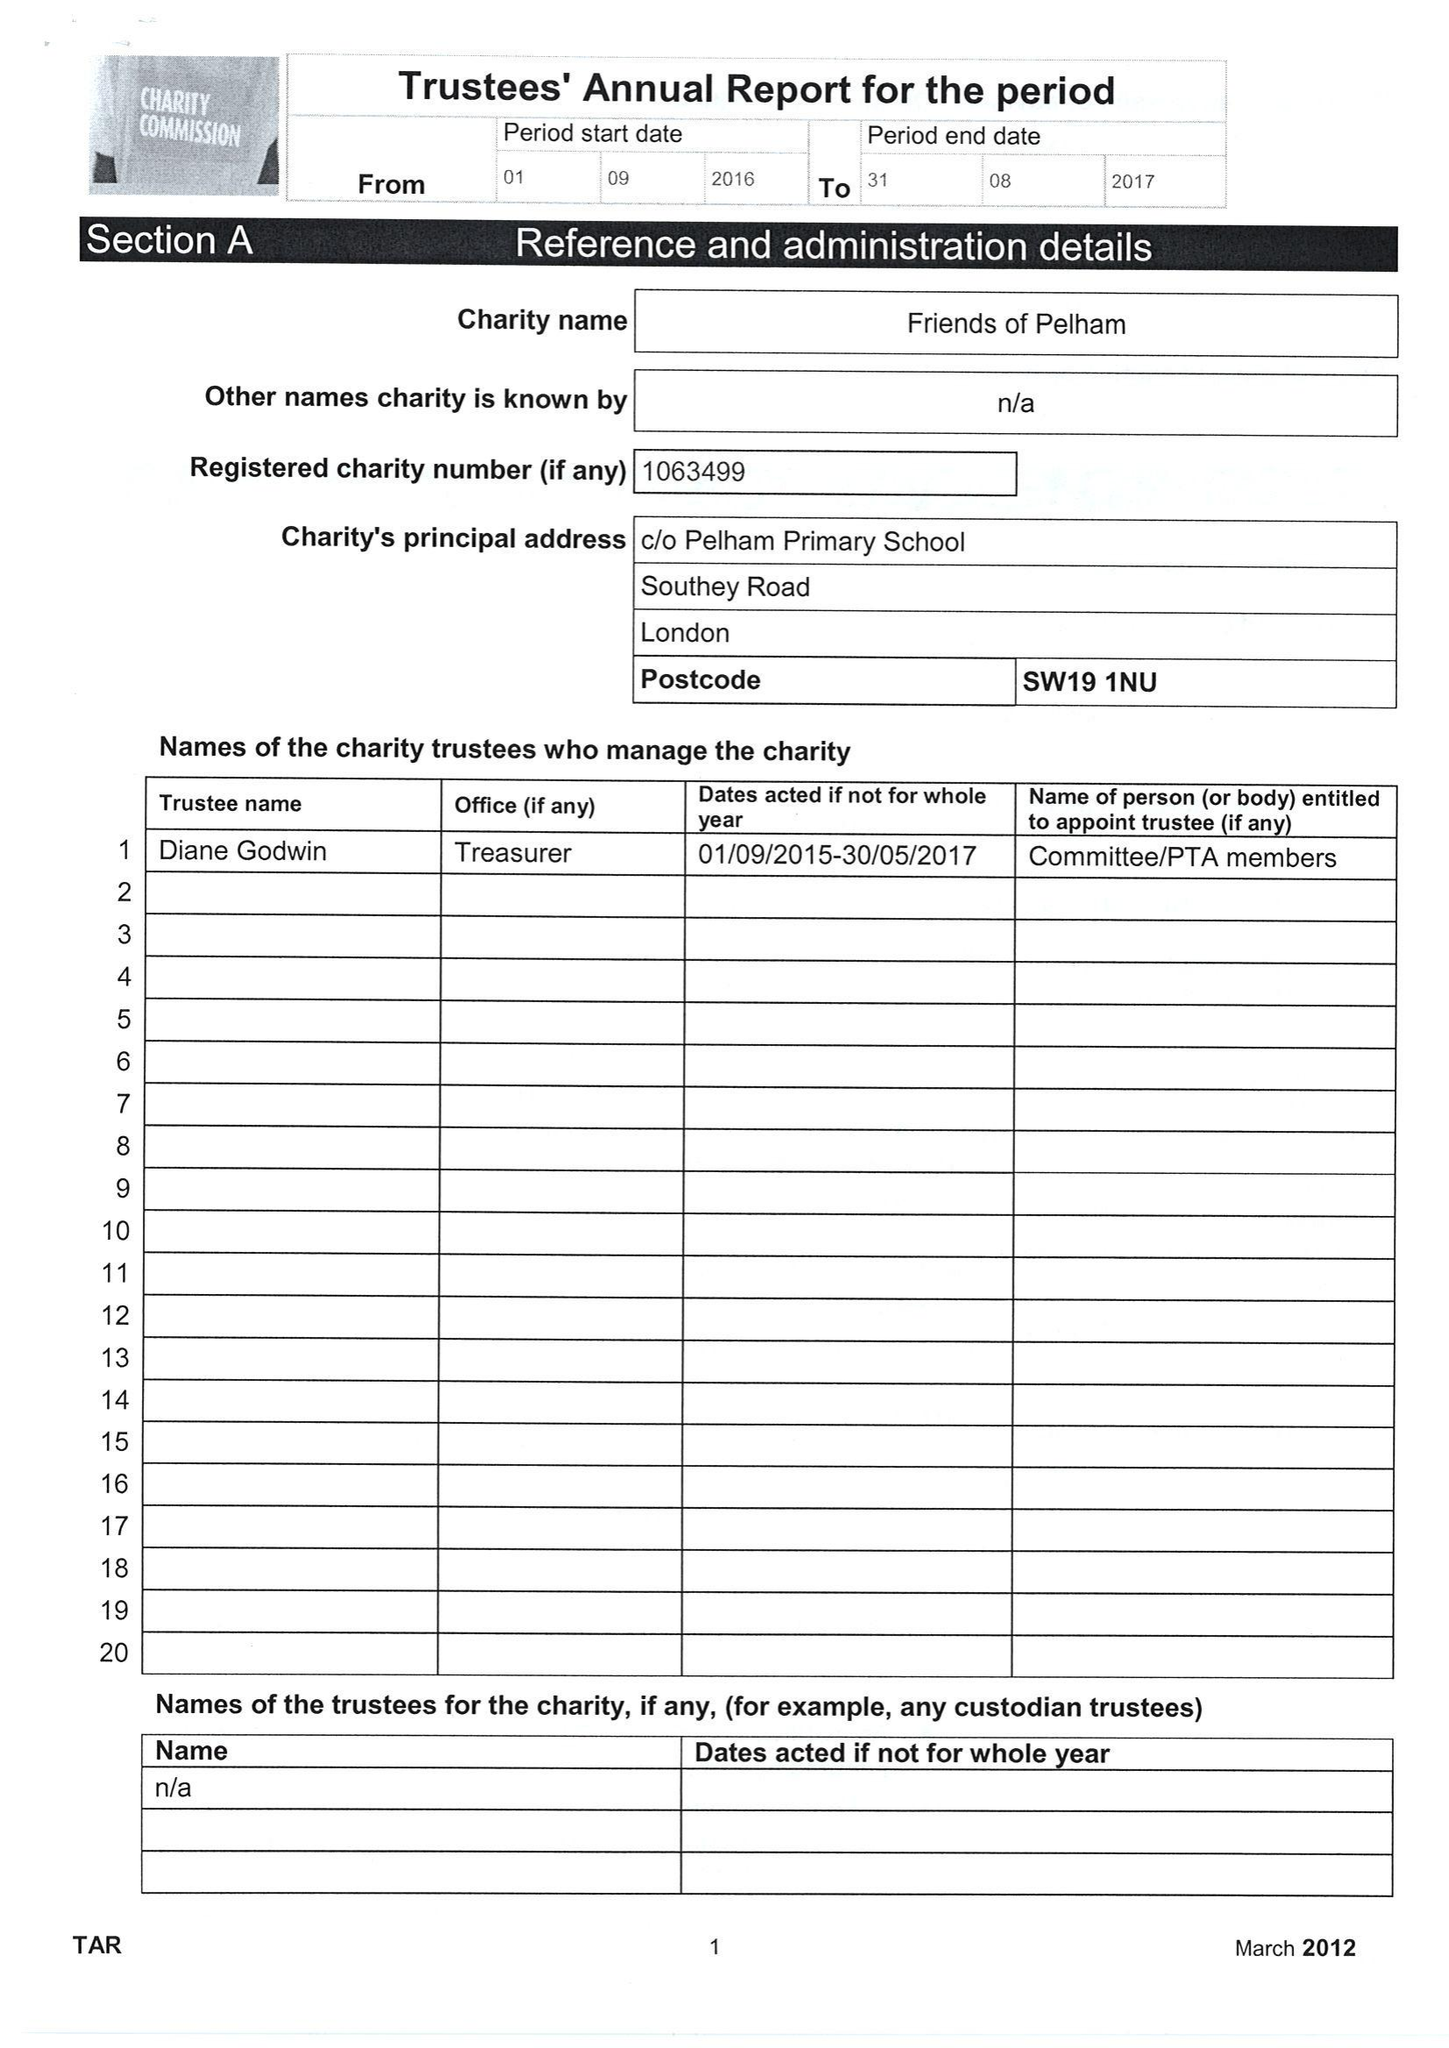What is the value for the charity_name?
Answer the question using a single word or phrase. Friends Of Pelham 